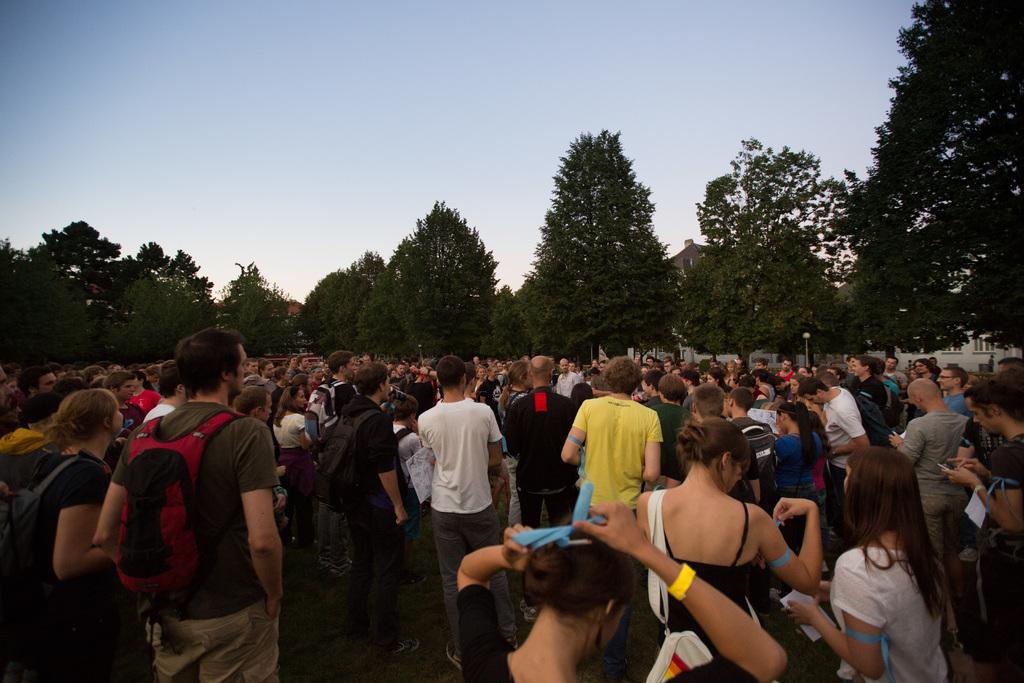Can you describe this image briefly? In this picture we can see a group of people standing on the path and in front of the people there is a pole, houses, trees and a sky. 